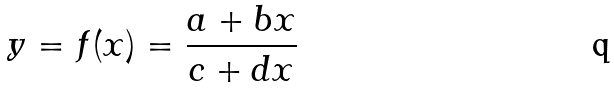Convert formula to latex. <formula><loc_0><loc_0><loc_500><loc_500>y = f ( x ) = \frac { a + b x } { c + d x }</formula> 